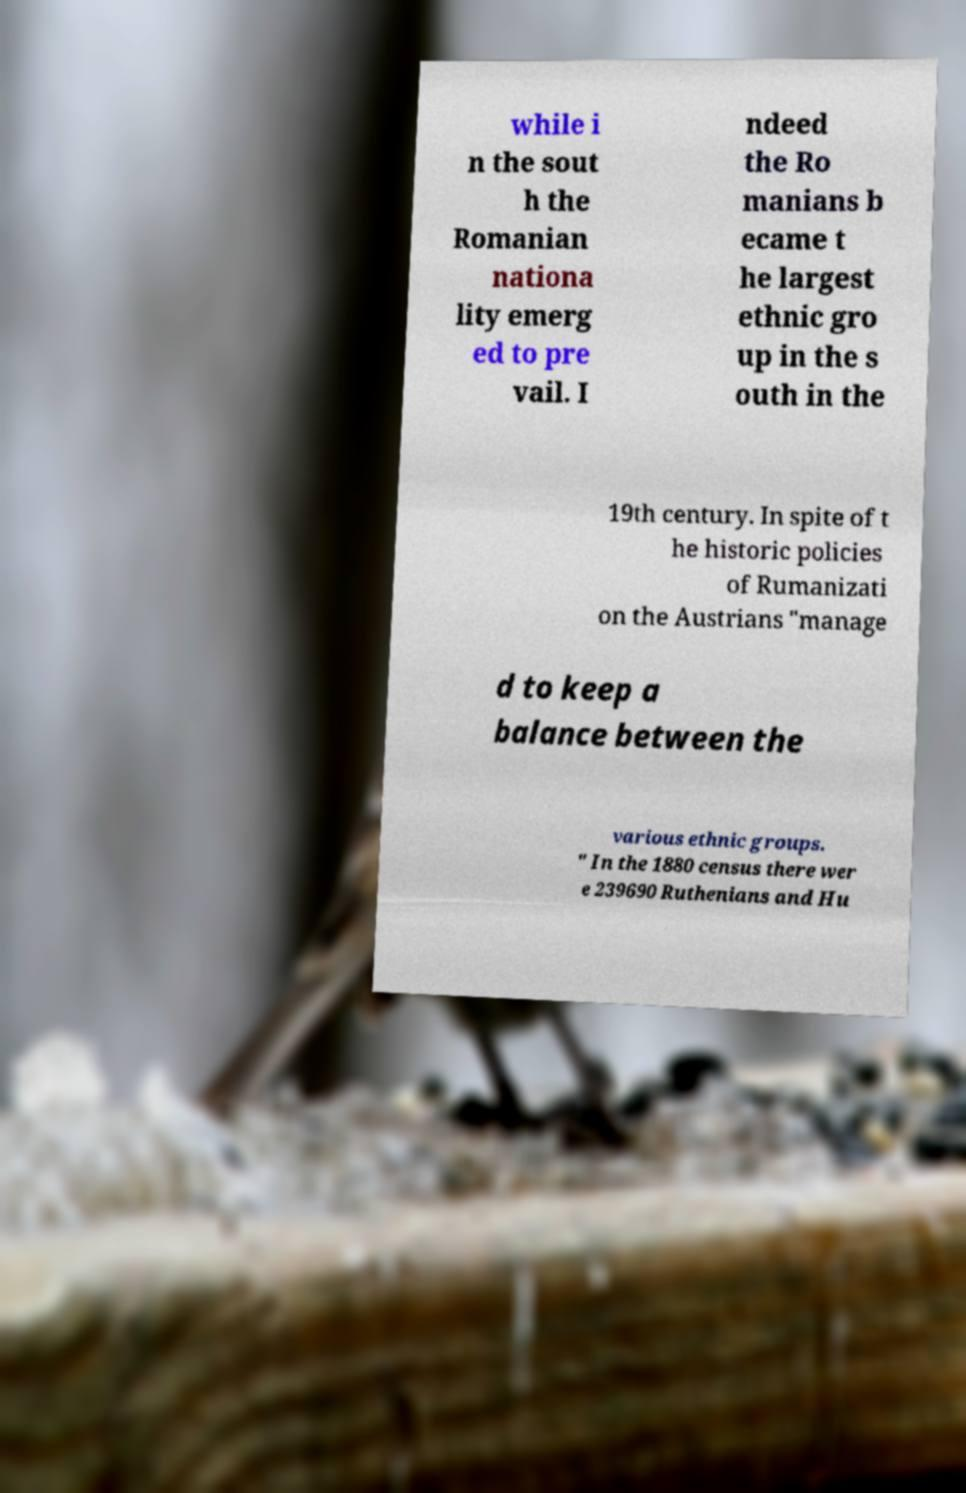For documentation purposes, I need the text within this image transcribed. Could you provide that? while i n the sout h the Romanian nationa lity emerg ed to pre vail. I ndeed the Ro manians b ecame t he largest ethnic gro up in the s outh in the 19th century. In spite of t he historic policies of Rumanizati on the Austrians "manage d to keep a balance between the various ethnic groups. " In the 1880 census there wer e 239690 Ruthenians and Hu 